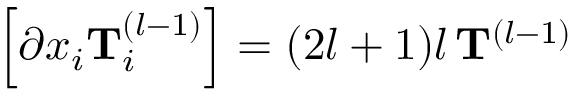Convert formula to latex. <formula><loc_0><loc_0><loc_500><loc_500>\left [ \partial x _ { i } T _ { i } ^ { ( l - 1 ) } \right ] = ( 2 l + 1 ) l \, T ^ { ( l - 1 ) }</formula> 